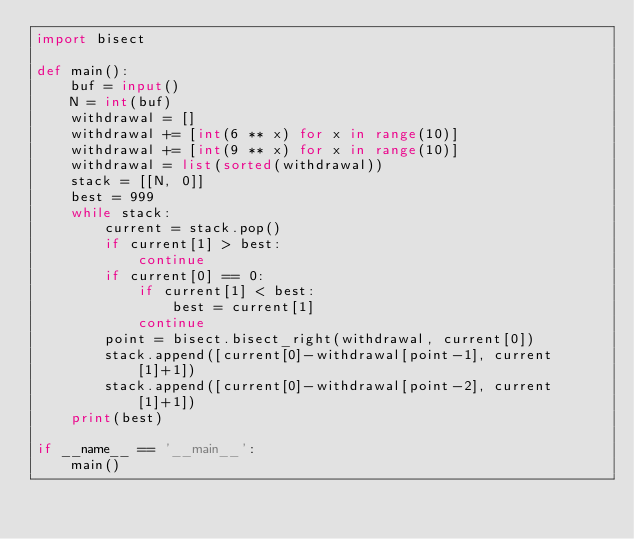<code> <loc_0><loc_0><loc_500><loc_500><_Python_>import bisect

def main():
    buf = input()
    N = int(buf)
    withdrawal = []
    withdrawal += [int(6 ** x) for x in range(10)]
    withdrawal += [int(9 ** x) for x in range(10)]
    withdrawal = list(sorted(withdrawal))
    stack = [[N, 0]]
    best = 999
    while stack:
        current = stack.pop()
        if current[1] > best:
            continue
        if current[0] == 0:
            if current[1] < best:
                best = current[1]
            continue
        point = bisect.bisect_right(withdrawal, current[0])
        stack.append([current[0]-withdrawal[point-1], current[1]+1])
        stack.append([current[0]-withdrawal[point-2], current[1]+1])
    print(best)

if __name__ == '__main__':
    main()
</code> 